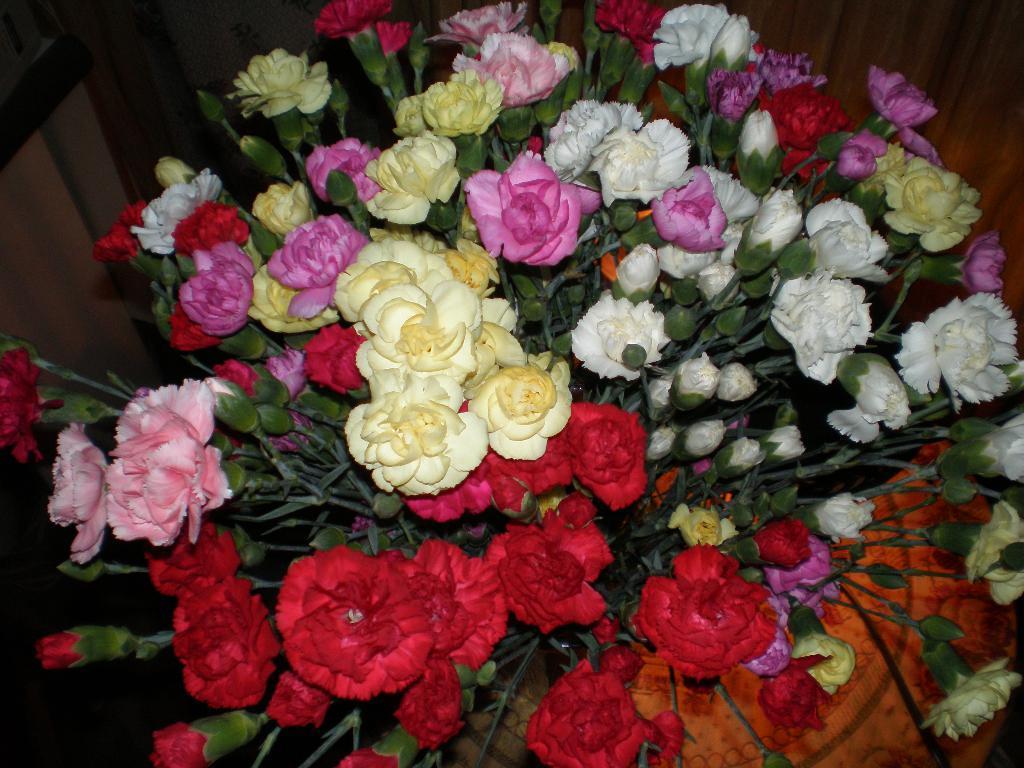Could you give a brief overview of what you see in this image? This image there are few stems having flowers, leaves and buds. Right top there is a wooden material. 